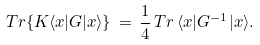<formula> <loc_0><loc_0><loc_500><loc_500>T r \{ K \langle { x } | G | { x } \rangle \} \, = \, \frac { 1 } { 4 } \, T r \, { \langle { x } | G ^ { - 1 } | { x } \rangle } .</formula> 